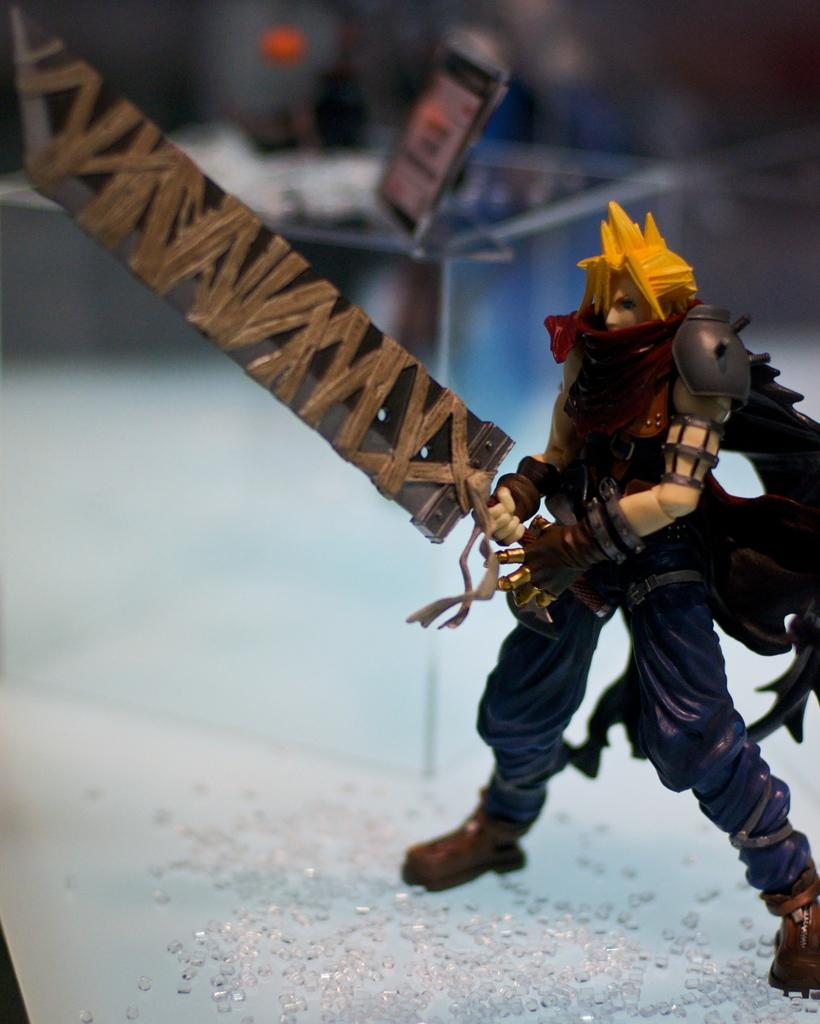What type of object can be seen in the image? There is a toy in the image. What other items are present in the image? There are crystals and a glass container in the image. Can you describe the object on the backside of the glass container? Unfortunately, the facts provided do not give enough information to describe the object on the backside of the glass container. What type of behavior can be observed in the crystals in the image? There is no behavior to observe in the crystals, as they are inanimate objects. 